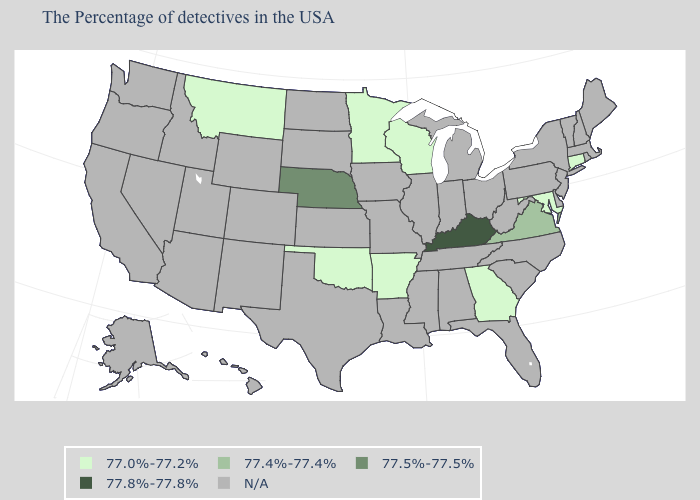Does the first symbol in the legend represent the smallest category?
Quick response, please. Yes. Which states hav the highest value in the Northeast?
Be succinct. Connecticut. What is the value of Kansas?
Answer briefly. N/A. Is the legend a continuous bar?
Give a very brief answer. No. Name the states that have a value in the range 77.5%-77.5%?
Short answer required. Nebraska. Among the states that border West Virginia , which have the lowest value?
Answer briefly. Maryland. Does Kentucky have the highest value in the USA?
Quick response, please. Yes. What is the value of Nevada?
Be succinct. N/A. Name the states that have a value in the range 77.0%-77.2%?
Be succinct. Connecticut, Maryland, Georgia, Wisconsin, Arkansas, Minnesota, Oklahoma, Montana. Name the states that have a value in the range 77.4%-77.4%?
Write a very short answer. Virginia. Which states have the lowest value in the MidWest?
Answer briefly. Wisconsin, Minnesota. Name the states that have a value in the range 77.8%-77.8%?
Concise answer only. Kentucky. 